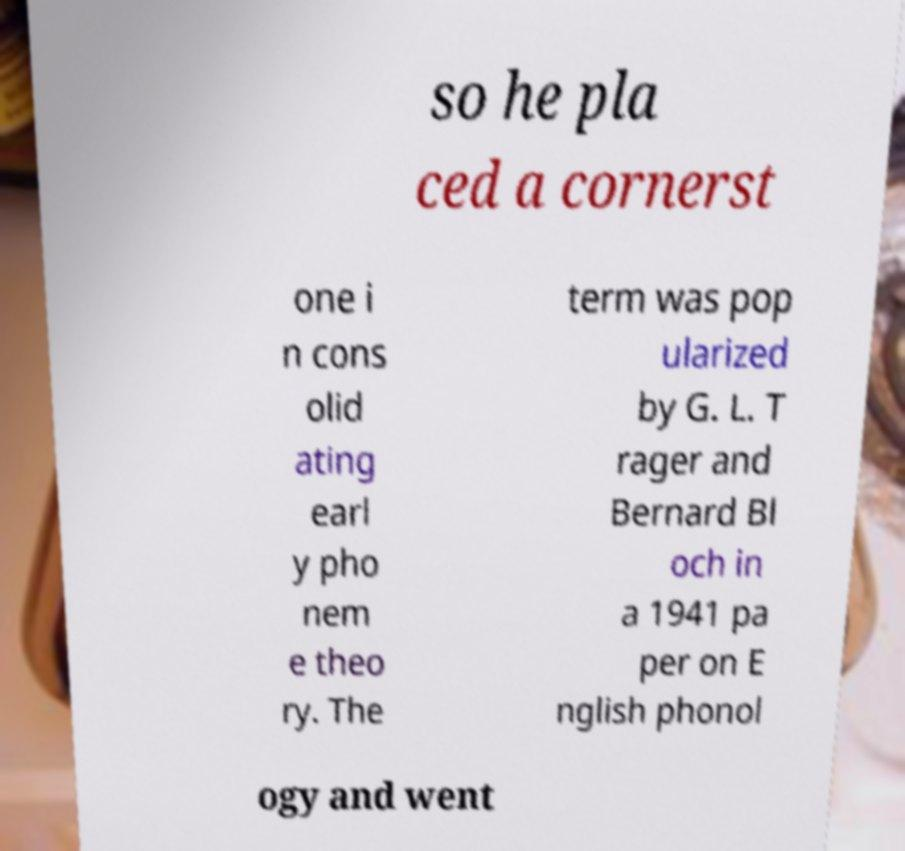Could you extract and type out the text from this image? so he pla ced a cornerst one i n cons olid ating earl y pho nem e theo ry. The term was pop ularized by G. L. T rager and Bernard Bl och in a 1941 pa per on E nglish phonol ogy and went 